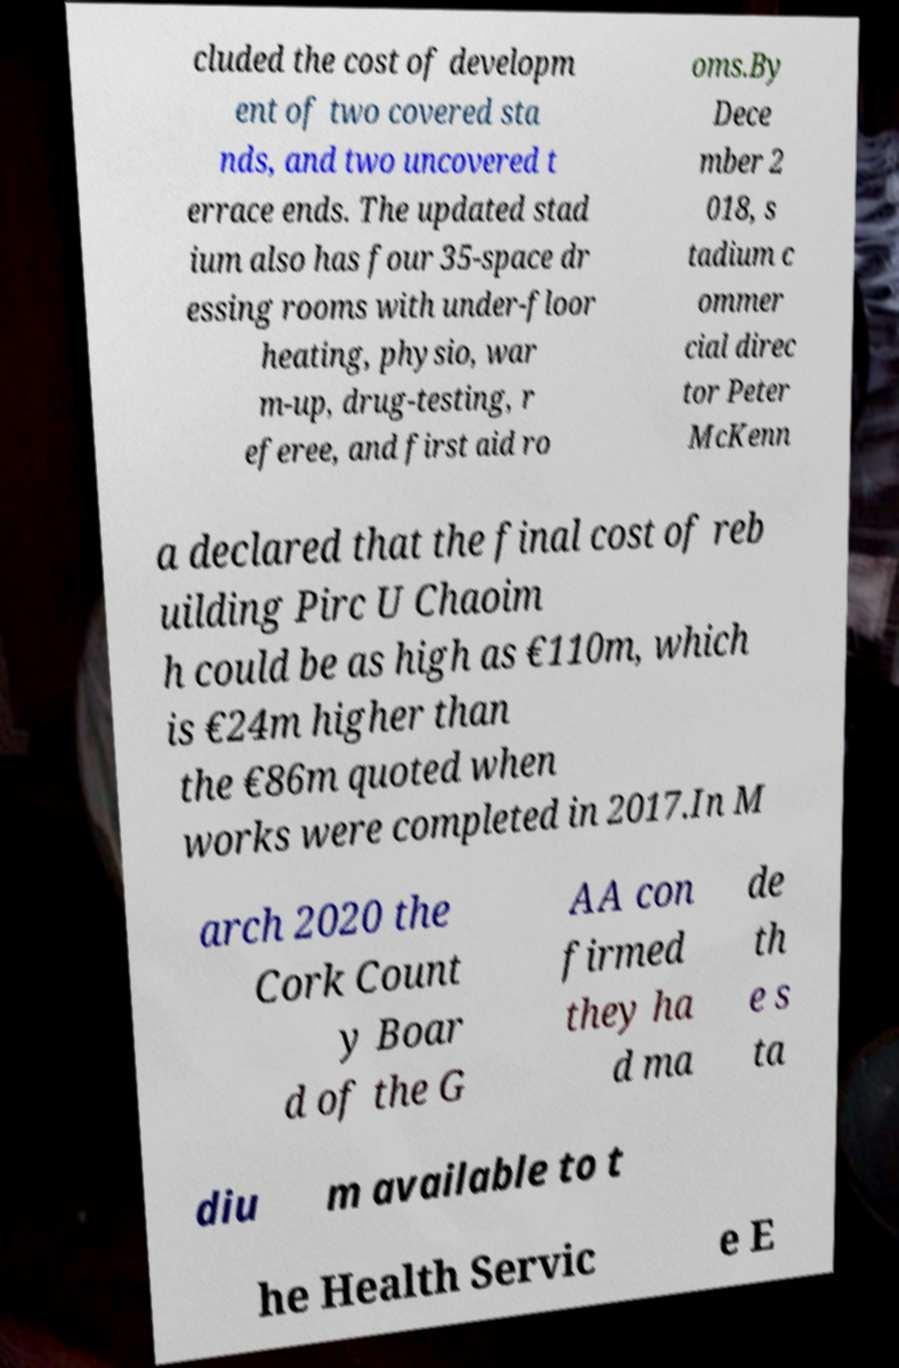I need the written content from this picture converted into text. Can you do that? cluded the cost of developm ent of two covered sta nds, and two uncovered t errace ends. The updated stad ium also has four 35-space dr essing rooms with under-floor heating, physio, war m-up, drug-testing, r eferee, and first aid ro oms.By Dece mber 2 018, s tadium c ommer cial direc tor Peter McKenn a declared that the final cost of reb uilding Pirc U Chaoim h could be as high as €110m, which is €24m higher than the €86m quoted when works were completed in 2017.In M arch 2020 the Cork Count y Boar d of the G AA con firmed they ha d ma de th e s ta diu m available to t he Health Servic e E 